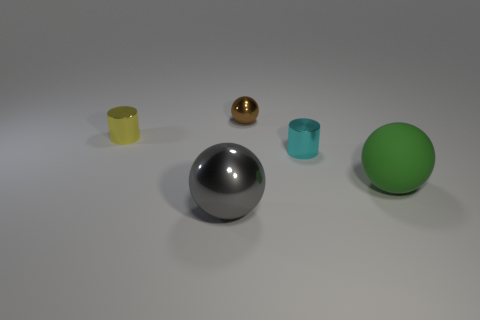How many things are big objects that are behind the gray shiny sphere or balls that are to the left of the small metal ball?
Offer a terse response. 2. What material is the big thing to the right of the metallic cylinder that is in front of the tiny metallic cylinder left of the gray ball?
Offer a very short reply. Rubber. There is a metal cylinder to the left of the tiny brown metal sphere; is its color the same as the matte object?
Your response must be concise. No. The object that is to the left of the brown object and on the right side of the yellow thing is made of what material?
Make the answer very short. Metal. Are there any gray spheres of the same size as the cyan cylinder?
Make the answer very short. No. How many small cylinders are there?
Give a very brief answer. 2. What number of big spheres are behind the green object?
Your answer should be compact. 0. Is the material of the tiny brown thing the same as the green sphere?
Provide a succinct answer. No. What number of objects are to the left of the cyan metal thing and behind the large green rubber object?
Offer a terse response. 2. What number of gray objects are large matte balls or spheres?
Your answer should be very brief. 1. 